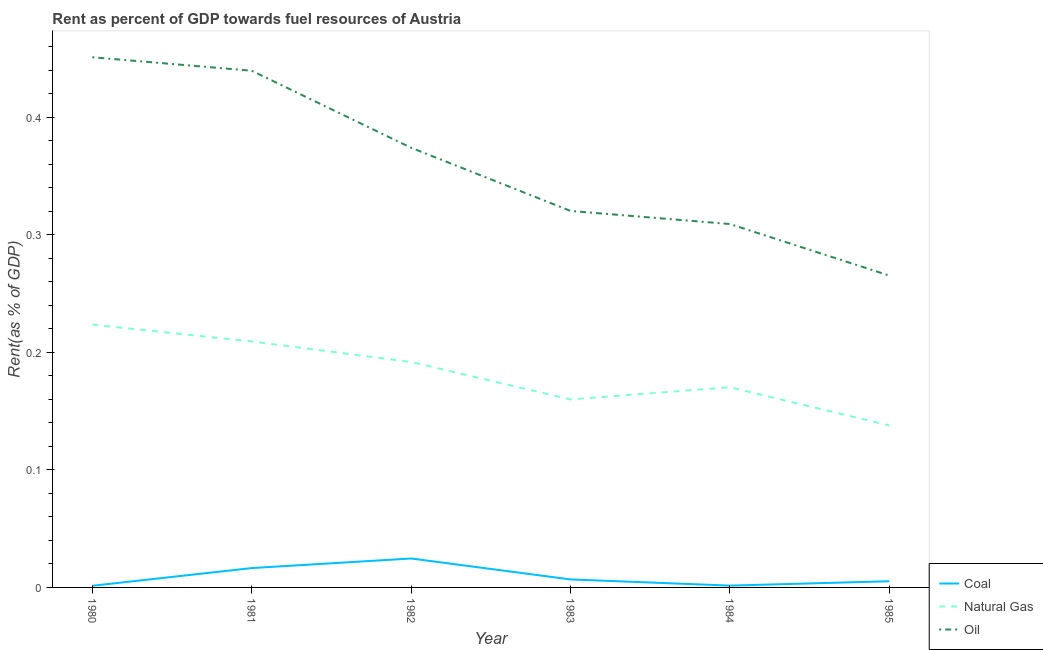How many different coloured lines are there?
Offer a terse response. 3. What is the rent towards coal in 1983?
Give a very brief answer. 0.01. Across all years, what is the maximum rent towards oil?
Provide a short and direct response. 0.45. Across all years, what is the minimum rent towards coal?
Provide a succinct answer. 0. In which year was the rent towards oil maximum?
Keep it short and to the point. 1980. In which year was the rent towards coal minimum?
Offer a very short reply. 1980. What is the total rent towards oil in the graph?
Your answer should be very brief. 2.16. What is the difference between the rent towards coal in 1981 and that in 1983?
Give a very brief answer. 0.01. What is the difference between the rent towards oil in 1984 and the rent towards coal in 1983?
Give a very brief answer. 0.3. What is the average rent towards coal per year?
Your answer should be compact. 0.01. In the year 1982, what is the difference between the rent towards natural gas and rent towards coal?
Keep it short and to the point. 0.17. In how many years, is the rent towards natural gas greater than 0.38000000000000006 %?
Offer a very short reply. 0. What is the ratio of the rent towards coal in 1983 to that in 1985?
Make the answer very short. 1.29. What is the difference between the highest and the second highest rent towards oil?
Give a very brief answer. 0.01. What is the difference between the highest and the lowest rent towards natural gas?
Your answer should be compact. 0.09. In how many years, is the rent towards oil greater than the average rent towards oil taken over all years?
Your response must be concise. 3. Is the sum of the rent towards coal in 1981 and 1982 greater than the maximum rent towards natural gas across all years?
Your answer should be very brief. No. Is the rent towards oil strictly greater than the rent towards natural gas over the years?
Make the answer very short. Yes. Is the rent towards oil strictly less than the rent towards natural gas over the years?
Provide a short and direct response. No. How many lines are there?
Ensure brevity in your answer.  3. How many years are there in the graph?
Provide a short and direct response. 6. Are the values on the major ticks of Y-axis written in scientific E-notation?
Your answer should be very brief. No. Where does the legend appear in the graph?
Provide a short and direct response. Bottom right. How many legend labels are there?
Provide a succinct answer. 3. How are the legend labels stacked?
Give a very brief answer. Vertical. What is the title of the graph?
Provide a short and direct response. Rent as percent of GDP towards fuel resources of Austria. What is the label or title of the X-axis?
Offer a terse response. Year. What is the label or title of the Y-axis?
Your response must be concise. Rent(as % of GDP). What is the Rent(as % of GDP) in Coal in 1980?
Your answer should be very brief. 0. What is the Rent(as % of GDP) in Natural Gas in 1980?
Make the answer very short. 0.22. What is the Rent(as % of GDP) in Oil in 1980?
Ensure brevity in your answer.  0.45. What is the Rent(as % of GDP) in Coal in 1981?
Your answer should be compact. 0.02. What is the Rent(as % of GDP) of Natural Gas in 1981?
Make the answer very short. 0.21. What is the Rent(as % of GDP) of Oil in 1981?
Ensure brevity in your answer.  0.44. What is the Rent(as % of GDP) in Coal in 1982?
Make the answer very short. 0.02. What is the Rent(as % of GDP) in Natural Gas in 1982?
Make the answer very short. 0.19. What is the Rent(as % of GDP) of Oil in 1982?
Give a very brief answer. 0.37. What is the Rent(as % of GDP) of Coal in 1983?
Your response must be concise. 0.01. What is the Rent(as % of GDP) of Natural Gas in 1983?
Your answer should be compact. 0.16. What is the Rent(as % of GDP) in Oil in 1983?
Provide a succinct answer. 0.32. What is the Rent(as % of GDP) in Coal in 1984?
Provide a short and direct response. 0. What is the Rent(as % of GDP) of Natural Gas in 1984?
Make the answer very short. 0.17. What is the Rent(as % of GDP) of Oil in 1984?
Provide a short and direct response. 0.31. What is the Rent(as % of GDP) of Coal in 1985?
Offer a very short reply. 0.01. What is the Rent(as % of GDP) in Natural Gas in 1985?
Your response must be concise. 0.14. What is the Rent(as % of GDP) in Oil in 1985?
Your answer should be compact. 0.27. Across all years, what is the maximum Rent(as % of GDP) of Coal?
Your response must be concise. 0.02. Across all years, what is the maximum Rent(as % of GDP) in Natural Gas?
Keep it short and to the point. 0.22. Across all years, what is the maximum Rent(as % of GDP) of Oil?
Your answer should be compact. 0.45. Across all years, what is the minimum Rent(as % of GDP) in Coal?
Your answer should be very brief. 0. Across all years, what is the minimum Rent(as % of GDP) in Natural Gas?
Offer a terse response. 0.14. Across all years, what is the minimum Rent(as % of GDP) in Oil?
Keep it short and to the point. 0.27. What is the total Rent(as % of GDP) of Coal in the graph?
Keep it short and to the point. 0.06. What is the total Rent(as % of GDP) of Natural Gas in the graph?
Provide a short and direct response. 1.09. What is the total Rent(as % of GDP) of Oil in the graph?
Provide a short and direct response. 2.16. What is the difference between the Rent(as % of GDP) in Coal in 1980 and that in 1981?
Make the answer very short. -0.02. What is the difference between the Rent(as % of GDP) in Natural Gas in 1980 and that in 1981?
Your answer should be very brief. 0.01. What is the difference between the Rent(as % of GDP) in Oil in 1980 and that in 1981?
Your answer should be compact. 0.01. What is the difference between the Rent(as % of GDP) of Coal in 1980 and that in 1982?
Make the answer very short. -0.02. What is the difference between the Rent(as % of GDP) in Natural Gas in 1980 and that in 1982?
Ensure brevity in your answer.  0.03. What is the difference between the Rent(as % of GDP) in Oil in 1980 and that in 1982?
Your response must be concise. 0.08. What is the difference between the Rent(as % of GDP) of Coal in 1980 and that in 1983?
Offer a terse response. -0.01. What is the difference between the Rent(as % of GDP) in Natural Gas in 1980 and that in 1983?
Offer a terse response. 0.06. What is the difference between the Rent(as % of GDP) of Oil in 1980 and that in 1983?
Keep it short and to the point. 0.13. What is the difference between the Rent(as % of GDP) of Coal in 1980 and that in 1984?
Your response must be concise. -0. What is the difference between the Rent(as % of GDP) in Natural Gas in 1980 and that in 1984?
Offer a very short reply. 0.05. What is the difference between the Rent(as % of GDP) of Oil in 1980 and that in 1984?
Keep it short and to the point. 0.14. What is the difference between the Rent(as % of GDP) in Coal in 1980 and that in 1985?
Your response must be concise. -0. What is the difference between the Rent(as % of GDP) of Natural Gas in 1980 and that in 1985?
Provide a short and direct response. 0.09. What is the difference between the Rent(as % of GDP) in Oil in 1980 and that in 1985?
Provide a short and direct response. 0.19. What is the difference between the Rent(as % of GDP) in Coal in 1981 and that in 1982?
Offer a very short reply. -0.01. What is the difference between the Rent(as % of GDP) of Natural Gas in 1981 and that in 1982?
Provide a short and direct response. 0.02. What is the difference between the Rent(as % of GDP) in Oil in 1981 and that in 1982?
Your answer should be compact. 0.07. What is the difference between the Rent(as % of GDP) in Coal in 1981 and that in 1983?
Give a very brief answer. 0.01. What is the difference between the Rent(as % of GDP) in Natural Gas in 1981 and that in 1983?
Ensure brevity in your answer.  0.05. What is the difference between the Rent(as % of GDP) of Oil in 1981 and that in 1983?
Give a very brief answer. 0.12. What is the difference between the Rent(as % of GDP) in Coal in 1981 and that in 1984?
Offer a terse response. 0.01. What is the difference between the Rent(as % of GDP) in Natural Gas in 1981 and that in 1984?
Keep it short and to the point. 0.04. What is the difference between the Rent(as % of GDP) in Oil in 1981 and that in 1984?
Your answer should be compact. 0.13. What is the difference between the Rent(as % of GDP) in Coal in 1981 and that in 1985?
Your answer should be compact. 0.01. What is the difference between the Rent(as % of GDP) in Natural Gas in 1981 and that in 1985?
Provide a short and direct response. 0.07. What is the difference between the Rent(as % of GDP) of Oil in 1981 and that in 1985?
Your answer should be very brief. 0.17. What is the difference between the Rent(as % of GDP) of Coal in 1982 and that in 1983?
Make the answer very short. 0.02. What is the difference between the Rent(as % of GDP) in Natural Gas in 1982 and that in 1983?
Keep it short and to the point. 0.03. What is the difference between the Rent(as % of GDP) in Oil in 1982 and that in 1983?
Provide a succinct answer. 0.05. What is the difference between the Rent(as % of GDP) of Coal in 1982 and that in 1984?
Make the answer very short. 0.02. What is the difference between the Rent(as % of GDP) in Natural Gas in 1982 and that in 1984?
Keep it short and to the point. 0.02. What is the difference between the Rent(as % of GDP) in Oil in 1982 and that in 1984?
Offer a terse response. 0.06. What is the difference between the Rent(as % of GDP) of Coal in 1982 and that in 1985?
Your response must be concise. 0.02. What is the difference between the Rent(as % of GDP) of Natural Gas in 1982 and that in 1985?
Keep it short and to the point. 0.05. What is the difference between the Rent(as % of GDP) in Oil in 1982 and that in 1985?
Offer a very short reply. 0.11. What is the difference between the Rent(as % of GDP) in Coal in 1983 and that in 1984?
Offer a very short reply. 0.01. What is the difference between the Rent(as % of GDP) of Natural Gas in 1983 and that in 1984?
Keep it short and to the point. -0.01. What is the difference between the Rent(as % of GDP) in Oil in 1983 and that in 1984?
Your answer should be very brief. 0.01. What is the difference between the Rent(as % of GDP) of Coal in 1983 and that in 1985?
Provide a short and direct response. 0. What is the difference between the Rent(as % of GDP) in Natural Gas in 1983 and that in 1985?
Offer a terse response. 0.02. What is the difference between the Rent(as % of GDP) of Oil in 1983 and that in 1985?
Your response must be concise. 0.06. What is the difference between the Rent(as % of GDP) in Coal in 1984 and that in 1985?
Your answer should be compact. -0. What is the difference between the Rent(as % of GDP) of Natural Gas in 1984 and that in 1985?
Your response must be concise. 0.03. What is the difference between the Rent(as % of GDP) in Oil in 1984 and that in 1985?
Make the answer very short. 0.04. What is the difference between the Rent(as % of GDP) of Coal in 1980 and the Rent(as % of GDP) of Natural Gas in 1981?
Your answer should be very brief. -0.21. What is the difference between the Rent(as % of GDP) in Coal in 1980 and the Rent(as % of GDP) in Oil in 1981?
Give a very brief answer. -0.44. What is the difference between the Rent(as % of GDP) of Natural Gas in 1980 and the Rent(as % of GDP) of Oil in 1981?
Provide a short and direct response. -0.22. What is the difference between the Rent(as % of GDP) in Coal in 1980 and the Rent(as % of GDP) in Natural Gas in 1982?
Provide a succinct answer. -0.19. What is the difference between the Rent(as % of GDP) of Coal in 1980 and the Rent(as % of GDP) of Oil in 1982?
Keep it short and to the point. -0.37. What is the difference between the Rent(as % of GDP) of Natural Gas in 1980 and the Rent(as % of GDP) of Oil in 1982?
Your response must be concise. -0.15. What is the difference between the Rent(as % of GDP) of Coal in 1980 and the Rent(as % of GDP) of Natural Gas in 1983?
Give a very brief answer. -0.16. What is the difference between the Rent(as % of GDP) of Coal in 1980 and the Rent(as % of GDP) of Oil in 1983?
Your response must be concise. -0.32. What is the difference between the Rent(as % of GDP) in Natural Gas in 1980 and the Rent(as % of GDP) in Oil in 1983?
Give a very brief answer. -0.1. What is the difference between the Rent(as % of GDP) in Coal in 1980 and the Rent(as % of GDP) in Natural Gas in 1984?
Your answer should be very brief. -0.17. What is the difference between the Rent(as % of GDP) of Coal in 1980 and the Rent(as % of GDP) of Oil in 1984?
Give a very brief answer. -0.31. What is the difference between the Rent(as % of GDP) of Natural Gas in 1980 and the Rent(as % of GDP) of Oil in 1984?
Provide a succinct answer. -0.09. What is the difference between the Rent(as % of GDP) in Coal in 1980 and the Rent(as % of GDP) in Natural Gas in 1985?
Your answer should be compact. -0.14. What is the difference between the Rent(as % of GDP) in Coal in 1980 and the Rent(as % of GDP) in Oil in 1985?
Your answer should be very brief. -0.26. What is the difference between the Rent(as % of GDP) of Natural Gas in 1980 and the Rent(as % of GDP) of Oil in 1985?
Provide a succinct answer. -0.04. What is the difference between the Rent(as % of GDP) of Coal in 1981 and the Rent(as % of GDP) of Natural Gas in 1982?
Your response must be concise. -0.18. What is the difference between the Rent(as % of GDP) in Coal in 1981 and the Rent(as % of GDP) in Oil in 1982?
Provide a succinct answer. -0.36. What is the difference between the Rent(as % of GDP) in Natural Gas in 1981 and the Rent(as % of GDP) in Oil in 1982?
Your answer should be very brief. -0.16. What is the difference between the Rent(as % of GDP) in Coal in 1981 and the Rent(as % of GDP) in Natural Gas in 1983?
Your response must be concise. -0.14. What is the difference between the Rent(as % of GDP) in Coal in 1981 and the Rent(as % of GDP) in Oil in 1983?
Keep it short and to the point. -0.3. What is the difference between the Rent(as % of GDP) of Natural Gas in 1981 and the Rent(as % of GDP) of Oil in 1983?
Give a very brief answer. -0.11. What is the difference between the Rent(as % of GDP) of Coal in 1981 and the Rent(as % of GDP) of Natural Gas in 1984?
Offer a very short reply. -0.15. What is the difference between the Rent(as % of GDP) of Coal in 1981 and the Rent(as % of GDP) of Oil in 1984?
Make the answer very short. -0.29. What is the difference between the Rent(as % of GDP) of Natural Gas in 1981 and the Rent(as % of GDP) of Oil in 1984?
Ensure brevity in your answer.  -0.1. What is the difference between the Rent(as % of GDP) in Coal in 1981 and the Rent(as % of GDP) in Natural Gas in 1985?
Provide a succinct answer. -0.12. What is the difference between the Rent(as % of GDP) in Coal in 1981 and the Rent(as % of GDP) in Oil in 1985?
Provide a succinct answer. -0.25. What is the difference between the Rent(as % of GDP) in Natural Gas in 1981 and the Rent(as % of GDP) in Oil in 1985?
Keep it short and to the point. -0.06. What is the difference between the Rent(as % of GDP) in Coal in 1982 and the Rent(as % of GDP) in Natural Gas in 1983?
Give a very brief answer. -0.14. What is the difference between the Rent(as % of GDP) in Coal in 1982 and the Rent(as % of GDP) in Oil in 1983?
Make the answer very short. -0.3. What is the difference between the Rent(as % of GDP) of Natural Gas in 1982 and the Rent(as % of GDP) of Oil in 1983?
Ensure brevity in your answer.  -0.13. What is the difference between the Rent(as % of GDP) in Coal in 1982 and the Rent(as % of GDP) in Natural Gas in 1984?
Provide a succinct answer. -0.15. What is the difference between the Rent(as % of GDP) of Coal in 1982 and the Rent(as % of GDP) of Oil in 1984?
Offer a very short reply. -0.28. What is the difference between the Rent(as % of GDP) of Natural Gas in 1982 and the Rent(as % of GDP) of Oil in 1984?
Your answer should be compact. -0.12. What is the difference between the Rent(as % of GDP) in Coal in 1982 and the Rent(as % of GDP) in Natural Gas in 1985?
Your answer should be very brief. -0.11. What is the difference between the Rent(as % of GDP) in Coal in 1982 and the Rent(as % of GDP) in Oil in 1985?
Provide a succinct answer. -0.24. What is the difference between the Rent(as % of GDP) in Natural Gas in 1982 and the Rent(as % of GDP) in Oil in 1985?
Offer a terse response. -0.07. What is the difference between the Rent(as % of GDP) of Coal in 1983 and the Rent(as % of GDP) of Natural Gas in 1984?
Provide a succinct answer. -0.16. What is the difference between the Rent(as % of GDP) of Coal in 1983 and the Rent(as % of GDP) of Oil in 1984?
Keep it short and to the point. -0.3. What is the difference between the Rent(as % of GDP) in Natural Gas in 1983 and the Rent(as % of GDP) in Oil in 1984?
Keep it short and to the point. -0.15. What is the difference between the Rent(as % of GDP) of Coal in 1983 and the Rent(as % of GDP) of Natural Gas in 1985?
Your answer should be compact. -0.13. What is the difference between the Rent(as % of GDP) in Coal in 1983 and the Rent(as % of GDP) in Oil in 1985?
Your answer should be very brief. -0.26. What is the difference between the Rent(as % of GDP) of Natural Gas in 1983 and the Rent(as % of GDP) of Oil in 1985?
Give a very brief answer. -0.11. What is the difference between the Rent(as % of GDP) in Coal in 1984 and the Rent(as % of GDP) in Natural Gas in 1985?
Provide a short and direct response. -0.14. What is the difference between the Rent(as % of GDP) of Coal in 1984 and the Rent(as % of GDP) of Oil in 1985?
Provide a succinct answer. -0.26. What is the difference between the Rent(as % of GDP) of Natural Gas in 1984 and the Rent(as % of GDP) of Oil in 1985?
Provide a succinct answer. -0.1. What is the average Rent(as % of GDP) in Coal per year?
Ensure brevity in your answer.  0.01. What is the average Rent(as % of GDP) of Natural Gas per year?
Give a very brief answer. 0.18. What is the average Rent(as % of GDP) of Oil per year?
Provide a short and direct response. 0.36. In the year 1980, what is the difference between the Rent(as % of GDP) in Coal and Rent(as % of GDP) in Natural Gas?
Provide a short and direct response. -0.22. In the year 1980, what is the difference between the Rent(as % of GDP) in Coal and Rent(as % of GDP) in Oil?
Give a very brief answer. -0.45. In the year 1980, what is the difference between the Rent(as % of GDP) in Natural Gas and Rent(as % of GDP) in Oil?
Offer a terse response. -0.23. In the year 1981, what is the difference between the Rent(as % of GDP) of Coal and Rent(as % of GDP) of Natural Gas?
Keep it short and to the point. -0.19. In the year 1981, what is the difference between the Rent(as % of GDP) in Coal and Rent(as % of GDP) in Oil?
Provide a succinct answer. -0.42. In the year 1981, what is the difference between the Rent(as % of GDP) in Natural Gas and Rent(as % of GDP) in Oil?
Provide a short and direct response. -0.23. In the year 1982, what is the difference between the Rent(as % of GDP) in Coal and Rent(as % of GDP) in Natural Gas?
Provide a short and direct response. -0.17. In the year 1982, what is the difference between the Rent(as % of GDP) of Coal and Rent(as % of GDP) of Oil?
Offer a terse response. -0.35. In the year 1982, what is the difference between the Rent(as % of GDP) of Natural Gas and Rent(as % of GDP) of Oil?
Offer a terse response. -0.18. In the year 1983, what is the difference between the Rent(as % of GDP) in Coal and Rent(as % of GDP) in Natural Gas?
Make the answer very short. -0.15. In the year 1983, what is the difference between the Rent(as % of GDP) in Coal and Rent(as % of GDP) in Oil?
Your answer should be compact. -0.31. In the year 1983, what is the difference between the Rent(as % of GDP) in Natural Gas and Rent(as % of GDP) in Oil?
Your answer should be compact. -0.16. In the year 1984, what is the difference between the Rent(as % of GDP) of Coal and Rent(as % of GDP) of Natural Gas?
Ensure brevity in your answer.  -0.17. In the year 1984, what is the difference between the Rent(as % of GDP) in Coal and Rent(as % of GDP) in Oil?
Make the answer very short. -0.31. In the year 1984, what is the difference between the Rent(as % of GDP) of Natural Gas and Rent(as % of GDP) of Oil?
Give a very brief answer. -0.14. In the year 1985, what is the difference between the Rent(as % of GDP) of Coal and Rent(as % of GDP) of Natural Gas?
Give a very brief answer. -0.13. In the year 1985, what is the difference between the Rent(as % of GDP) in Coal and Rent(as % of GDP) in Oil?
Offer a very short reply. -0.26. In the year 1985, what is the difference between the Rent(as % of GDP) of Natural Gas and Rent(as % of GDP) of Oil?
Your response must be concise. -0.13. What is the ratio of the Rent(as % of GDP) of Coal in 1980 to that in 1981?
Provide a succinct answer. 0.09. What is the ratio of the Rent(as % of GDP) of Natural Gas in 1980 to that in 1981?
Offer a very short reply. 1.07. What is the ratio of the Rent(as % of GDP) in Oil in 1980 to that in 1981?
Ensure brevity in your answer.  1.03. What is the ratio of the Rent(as % of GDP) of Coal in 1980 to that in 1982?
Give a very brief answer. 0.06. What is the ratio of the Rent(as % of GDP) in Natural Gas in 1980 to that in 1982?
Make the answer very short. 1.17. What is the ratio of the Rent(as % of GDP) of Oil in 1980 to that in 1982?
Provide a succinct answer. 1.21. What is the ratio of the Rent(as % of GDP) of Coal in 1980 to that in 1983?
Provide a short and direct response. 0.21. What is the ratio of the Rent(as % of GDP) in Natural Gas in 1980 to that in 1983?
Your response must be concise. 1.4. What is the ratio of the Rent(as % of GDP) in Oil in 1980 to that in 1983?
Provide a succinct answer. 1.41. What is the ratio of the Rent(as % of GDP) of Coal in 1980 to that in 1984?
Your answer should be compact. 0.91. What is the ratio of the Rent(as % of GDP) of Natural Gas in 1980 to that in 1984?
Your response must be concise. 1.31. What is the ratio of the Rent(as % of GDP) of Oil in 1980 to that in 1984?
Provide a short and direct response. 1.46. What is the ratio of the Rent(as % of GDP) in Coal in 1980 to that in 1985?
Give a very brief answer. 0.27. What is the ratio of the Rent(as % of GDP) in Natural Gas in 1980 to that in 1985?
Make the answer very short. 1.62. What is the ratio of the Rent(as % of GDP) in Oil in 1980 to that in 1985?
Offer a terse response. 1.7. What is the ratio of the Rent(as % of GDP) of Coal in 1981 to that in 1982?
Offer a very short reply. 0.67. What is the ratio of the Rent(as % of GDP) of Natural Gas in 1981 to that in 1982?
Ensure brevity in your answer.  1.09. What is the ratio of the Rent(as % of GDP) in Oil in 1981 to that in 1982?
Provide a short and direct response. 1.18. What is the ratio of the Rent(as % of GDP) of Coal in 1981 to that in 1983?
Offer a very short reply. 2.42. What is the ratio of the Rent(as % of GDP) in Natural Gas in 1981 to that in 1983?
Provide a short and direct response. 1.31. What is the ratio of the Rent(as % of GDP) of Oil in 1981 to that in 1983?
Keep it short and to the point. 1.37. What is the ratio of the Rent(as % of GDP) in Coal in 1981 to that in 1984?
Your answer should be compact. 10.69. What is the ratio of the Rent(as % of GDP) in Natural Gas in 1981 to that in 1984?
Provide a succinct answer. 1.23. What is the ratio of the Rent(as % of GDP) of Oil in 1981 to that in 1984?
Give a very brief answer. 1.42. What is the ratio of the Rent(as % of GDP) of Coal in 1981 to that in 1985?
Give a very brief answer. 3.13. What is the ratio of the Rent(as % of GDP) of Natural Gas in 1981 to that in 1985?
Your answer should be compact. 1.52. What is the ratio of the Rent(as % of GDP) in Oil in 1981 to that in 1985?
Ensure brevity in your answer.  1.66. What is the ratio of the Rent(as % of GDP) in Coal in 1982 to that in 1983?
Offer a very short reply. 3.62. What is the ratio of the Rent(as % of GDP) in Natural Gas in 1982 to that in 1983?
Your response must be concise. 1.2. What is the ratio of the Rent(as % of GDP) of Oil in 1982 to that in 1983?
Offer a very short reply. 1.17. What is the ratio of the Rent(as % of GDP) of Coal in 1982 to that in 1984?
Provide a short and direct response. 15.97. What is the ratio of the Rent(as % of GDP) in Natural Gas in 1982 to that in 1984?
Your response must be concise. 1.13. What is the ratio of the Rent(as % of GDP) of Oil in 1982 to that in 1984?
Your answer should be very brief. 1.21. What is the ratio of the Rent(as % of GDP) in Coal in 1982 to that in 1985?
Offer a terse response. 4.68. What is the ratio of the Rent(as % of GDP) of Natural Gas in 1982 to that in 1985?
Provide a short and direct response. 1.39. What is the ratio of the Rent(as % of GDP) of Oil in 1982 to that in 1985?
Ensure brevity in your answer.  1.41. What is the ratio of the Rent(as % of GDP) in Coal in 1983 to that in 1984?
Provide a short and direct response. 4.42. What is the ratio of the Rent(as % of GDP) in Natural Gas in 1983 to that in 1984?
Ensure brevity in your answer.  0.94. What is the ratio of the Rent(as % of GDP) in Oil in 1983 to that in 1984?
Your response must be concise. 1.04. What is the ratio of the Rent(as % of GDP) in Coal in 1983 to that in 1985?
Provide a short and direct response. 1.29. What is the ratio of the Rent(as % of GDP) in Natural Gas in 1983 to that in 1985?
Give a very brief answer. 1.16. What is the ratio of the Rent(as % of GDP) of Oil in 1983 to that in 1985?
Your answer should be compact. 1.21. What is the ratio of the Rent(as % of GDP) of Coal in 1984 to that in 1985?
Keep it short and to the point. 0.29. What is the ratio of the Rent(as % of GDP) in Natural Gas in 1984 to that in 1985?
Ensure brevity in your answer.  1.24. What is the ratio of the Rent(as % of GDP) in Oil in 1984 to that in 1985?
Keep it short and to the point. 1.17. What is the difference between the highest and the second highest Rent(as % of GDP) of Coal?
Your response must be concise. 0.01. What is the difference between the highest and the second highest Rent(as % of GDP) in Natural Gas?
Make the answer very short. 0.01. What is the difference between the highest and the second highest Rent(as % of GDP) of Oil?
Offer a terse response. 0.01. What is the difference between the highest and the lowest Rent(as % of GDP) of Coal?
Your answer should be compact. 0.02. What is the difference between the highest and the lowest Rent(as % of GDP) of Natural Gas?
Offer a terse response. 0.09. What is the difference between the highest and the lowest Rent(as % of GDP) of Oil?
Your response must be concise. 0.19. 